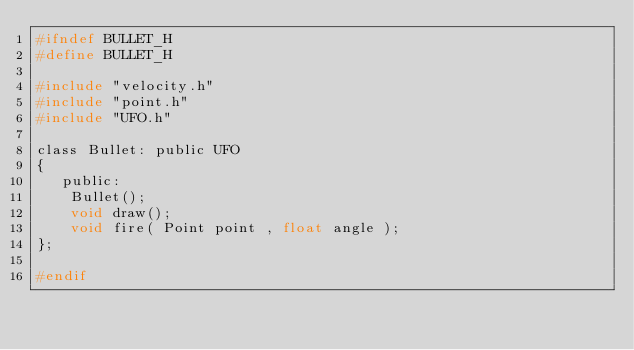<code> <loc_0><loc_0><loc_500><loc_500><_C_>#ifndef BULLET_H
#define BULLET_H

#include "velocity.h"
#include "point.h"
#include "UFO.h"

class Bullet: public UFO
{
   public:
   	Bullet();
   	void draw();
   	void fire( Point point , float angle );
};

#endif
</code> 